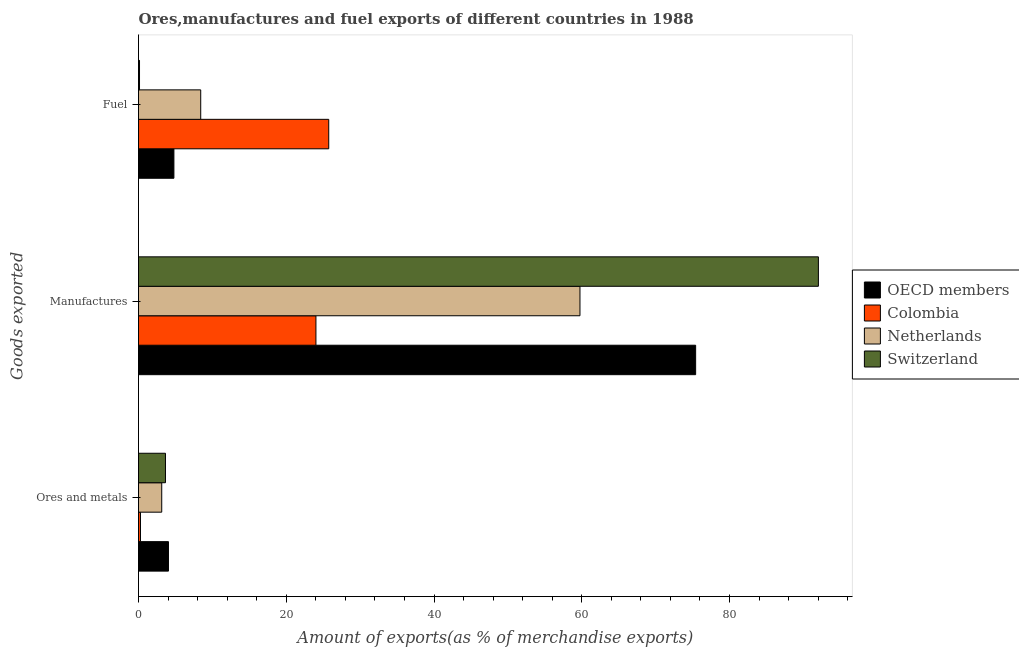How many different coloured bars are there?
Your response must be concise. 4. How many groups of bars are there?
Ensure brevity in your answer.  3. Are the number of bars per tick equal to the number of legend labels?
Your response must be concise. Yes. Are the number of bars on each tick of the Y-axis equal?
Make the answer very short. Yes. How many bars are there on the 3rd tick from the top?
Offer a terse response. 4. What is the label of the 1st group of bars from the top?
Offer a terse response. Fuel. What is the percentage of fuel exports in Netherlands?
Make the answer very short. 8.42. Across all countries, what is the maximum percentage of fuel exports?
Your response must be concise. 25.75. Across all countries, what is the minimum percentage of fuel exports?
Provide a short and direct response. 0.14. In which country was the percentage of manufactures exports maximum?
Provide a short and direct response. Switzerland. In which country was the percentage of fuel exports minimum?
Your answer should be compact. Switzerland. What is the total percentage of fuel exports in the graph?
Your response must be concise. 39.1. What is the difference between the percentage of fuel exports in Colombia and that in Switzerland?
Provide a short and direct response. 25.61. What is the difference between the percentage of manufactures exports in Switzerland and the percentage of ores and metals exports in Colombia?
Make the answer very short. 91.76. What is the average percentage of manufactures exports per country?
Your answer should be very brief. 62.81. What is the difference between the percentage of fuel exports and percentage of manufactures exports in Colombia?
Offer a very short reply. 1.73. What is the ratio of the percentage of ores and metals exports in Colombia to that in Switzerland?
Provide a succinct answer. 0.07. Is the percentage of fuel exports in Colombia less than that in Netherlands?
Give a very brief answer. No. Is the difference between the percentage of manufactures exports in Switzerland and Colombia greater than the difference between the percentage of ores and metals exports in Switzerland and Colombia?
Make the answer very short. Yes. What is the difference between the highest and the second highest percentage of manufactures exports?
Keep it short and to the point. 16.62. What is the difference between the highest and the lowest percentage of ores and metals exports?
Offer a very short reply. 3.79. In how many countries, is the percentage of fuel exports greater than the average percentage of fuel exports taken over all countries?
Keep it short and to the point. 1. Is the sum of the percentage of manufactures exports in Switzerland and Colombia greater than the maximum percentage of ores and metals exports across all countries?
Your answer should be very brief. Yes. What does the 1st bar from the top in Fuel represents?
Give a very brief answer. Switzerland. What does the 1st bar from the bottom in Manufactures represents?
Your answer should be compact. OECD members. Is it the case that in every country, the sum of the percentage of ores and metals exports and percentage of manufactures exports is greater than the percentage of fuel exports?
Offer a terse response. No. How many bars are there?
Your answer should be compact. 12. What is the difference between two consecutive major ticks on the X-axis?
Provide a succinct answer. 20. Where does the legend appear in the graph?
Offer a very short reply. Center right. How many legend labels are there?
Ensure brevity in your answer.  4. What is the title of the graph?
Provide a succinct answer. Ores,manufactures and fuel exports of different countries in 1988. What is the label or title of the X-axis?
Ensure brevity in your answer.  Amount of exports(as % of merchandise exports). What is the label or title of the Y-axis?
Give a very brief answer. Goods exported. What is the Amount of exports(as % of merchandise exports) in OECD members in Ores and metals?
Provide a succinct answer. 4.05. What is the Amount of exports(as % of merchandise exports) of Colombia in Ores and metals?
Ensure brevity in your answer.  0.27. What is the Amount of exports(as % of merchandise exports) in Netherlands in Ores and metals?
Offer a very short reply. 3.14. What is the Amount of exports(as % of merchandise exports) of Switzerland in Ores and metals?
Your answer should be very brief. 3.65. What is the Amount of exports(as % of merchandise exports) in OECD members in Manufactures?
Keep it short and to the point. 75.42. What is the Amount of exports(as % of merchandise exports) of Colombia in Manufactures?
Keep it short and to the point. 24.02. What is the Amount of exports(as % of merchandise exports) in Netherlands in Manufactures?
Your answer should be very brief. 59.76. What is the Amount of exports(as % of merchandise exports) of Switzerland in Manufactures?
Ensure brevity in your answer.  92.03. What is the Amount of exports(as % of merchandise exports) of OECD members in Fuel?
Make the answer very short. 4.79. What is the Amount of exports(as % of merchandise exports) in Colombia in Fuel?
Provide a succinct answer. 25.75. What is the Amount of exports(as % of merchandise exports) of Netherlands in Fuel?
Give a very brief answer. 8.42. What is the Amount of exports(as % of merchandise exports) of Switzerland in Fuel?
Keep it short and to the point. 0.14. Across all Goods exported, what is the maximum Amount of exports(as % of merchandise exports) in OECD members?
Provide a succinct answer. 75.42. Across all Goods exported, what is the maximum Amount of exports(as % of merchandise exports) in Colombia?
Make the answer very short. 25.75. Across all Goods exported, what is the maximum Amount of exports(as % of merchandise exports) in Netherlands?
Make the answer very short. 59.76. Across all Goods exported, what is the maximum Amount of exports(as % of merchandise exports) of Switzerland?
Your answer should be very brief. 92.03. Across all Goods exported, what is the minimum Amount of exports(as % of merchandise exports) in OECD members?
Your answer should be very brief. 4.05. Across all Goods exported, what is the minimum Amount of exports(as % of merchandise exports) of Colombia?
Your answer should be very brief. 0.27. Across all Goods exported, what is the minimum Amount of exports(as % of merchandise exports) of Netherlands?
Your response must be concise. 3.14. Across all Goods exported, what is the minimum Amount of exports(as % of merchandise exports) in Switzerland?
Offer a very short reply. 0.14. What is the total Amount of exports(as % of merchandise exports) in OECD members in the graph?
Your response must be concise. 84.26. What is the total Amount of exports(as % of merchandise exports) in Colombia in the graph?
Offer a terse response. 50.04. What is the total Amount of exports(as % of merchandise exports) of Netherlands in the graph?
Ensure brevity in your answer.  71.32. What is the total Amount of exports(as % of merchandise exports) of Switzerland in the graph?
Ensure brevity in your answer.  95.82. What is the difference between the Amount of exports(as % of merchandise exports) in OECD members in Ores and metals and that in Manufactures?
Offer a very short reply. -71.36. What is the difference between the Amount of exports(as % of merchandise exports) of Colombia in Ores and metals and that in Manufactures?
Make the answer very short. -23.75. What is the difference between the Amount of exports(as % of merchandise exports) of Netherlands in Ores and metals and that in Manufactures?
Provide a short and direct response. -56.62. What is the difference between the Amount of exports(as % of merchandise exports) in Switzerland in Ores and metals and that in Manufactures?
Your answer should be compact. -88.38. What is the difference between the Amount of exports(as % of merchandise exports) of OECD members in Ores and metals and that in Fuel?
Offer a terse response. -0.74. What is the difference between the Amount of exports(as % of merchandise exports) in Colombia in Ores and metals and that in Fuel?
Make the answer very short. -25.48. What is the difference between the Amount of exports(as % of merchandise exports) of Netherlands in Ores and metals and that in Fuel?
Make the answer very short. -5.28. What is the difference between the Amount of exports(as % of merchandise exports) of Switzerland in Ores and metals and that in Fuel?
Give a very brief answer. 3.51. What is the difference between the Amount of exports(as % of merchandise exports) in OECD members in Manufactures and that in Fuel?
Keep it short and to the point. 70.62. What is the difference between the Amount of exports(as % of merchandise exports) of Colombia in Manufactures and that in Fuel?
Give a very brief answer. -1.73. What is the difference between the Amount of exports(as % of merchandise exports) of Netherlands in Manufactures and that in Fuel?
Your answer should be very brief. 51.34. What is the difference between the Amount of exports(as % of merchandise exports) in Switzerland in Manufactures and that in Fuel?
Your answer should be compact. 91.9. What is the difference between the Amount of exports(as % of merchandise exports) in OECD members in Ores and metals and the Amount of exports(as % of merchandise exports) in Colombia in Manufactures?
Offer a terse response. -19.96. What is the difference between the Amount of exports(as % of merchandise exports) of OECD members in Ores and metals and the Amount of exports(as % of merchandise exports) of Netherlands in Manufactures?
Offer a very short reply. -55.7. What is the difference between the Amount of exports(as % of merchandise exports) of OECD members in Ores and metals and the Amount of exports(as % of merchandise exports) of Switzerland in Manufactures?
Ensure brevity in your answer.  -87.98. What is the difference between the Amount of exports(as % of merchandise exports) of Colombia in Ores and metals and the Amount of exports(as % of merchandise exports) of Netherlands in Manufactures?
Provide a short and direct response. -59.49. What is the difference between the Amount of exports(as % of merchandise exports) of Colombia in Ores and metals and the Amount of exports(as % of merchandise exports) of Switzerland in Manufactures?
Your answer should be very brief. -91.76. What is the difference between the Amount of exports(as % of merchandise exports) of Netherlands in Ores and metals and the Amount of exports(as % of merchandise exports) of Switzerland in Manufactures?
Your response must be concise. -88.89. What is the difference between the Amount of exports(as % of merchandise exports) of OECD members in Ores and metals and the Amount of exports(as % of merchandise exports) of Colombia in Fuel?
Make the answer very short. -21.7. What is the difference between the Amount of exports(as % of merchandise exports) in OECD members in Ores and metals and the Amount of exports(as % of merchandise exports) in Netherlands in Fuel?
Keep it short and to the point. -4.37. What is the difference between the Amount of exports(as % of merchandise exports) in OECD members in Ores and metals and the Amount of exports(as % of merchandise exports) in Switzerland in Fuel?
Your response must be concise. 3.92. What is the difference between the Amount of exports(as % of merchandise exports) in Colombia in Ores and metals and the Amount of exports(as % of merchandise exports) in Netherlands in Fuel?
Your answer should be very brief. -8.15. What is the difference between the Amount of exports(as % of merchandise exports) in Colombia in Ores and metals and the Amount of exports(as % of merchandise exports) in Switzerland in Fuel?
Make the answer very short. 0.13. What is the difference between the Amount of exports(as % of merchandise exports) of Netherlands in Ores and metals and the Amount of exports(as % of merchandise exports) of Switzerland in Fuel?
Provide a succinct answer. 3.01. What is the difference between the Amount of exports(as % of merchandise exports) of OECD members in Manufactures and the Amount of exports(as % of merchandise exports) of Colombia in Fuel?
Your answer should be compact. 49.67. What is the difference between the Amount of exports(as % of merchandise exports) of OECD members in Manufactures and the Amount of exports(as % of merchandise exports) of Netherlands in Fuel?
Offer a very short reply. 67. What is the difference between the Amount of exports(as % of merchandise exports) of OECD members in Manufactures and the Amount of exports(as % of merchandise exports) of Switzerland in Fuel?
Your answer should be compact. 75.28. What is the difference between the Amount of exports(as % of merchandise exports) of Colombia in Manufactures and the Amount of exports(as % of merchandise exports) of Netherlands in Fuel?
Your answer should be compact. 15.6. What is the difference between the Amount of exports(as % of merchandise exports) in Colombia in Manufactures and the Amount of exports(as % of merchandise exports) in Switzerland in Fuel?
Offer a terse response. 23.88. What is the difference between the Amount of exports(as % of merchandise exports) of Netherlands in Manufactures and the Amount of exports(as % of merchandise exports) of Switzerland in Fuel?
Give a very brief answer. 59.62. What is the average Amount of exports(as % of merchandise exports) in OECD members per Goods exported?
Offer a terse response. 28.09. What is the average Amount of exports(as % of merchandise exports) of Colombia per Goods exported?
Your answer should be very brief. 16.68. What is the average Amount of exports(as % of merchandise exports) of Netherlands per Goods exported?
Provide a succinct answer. 23.77. What is the average Amount of exports(as % of merchandise exports) of Switzerland per Goods exported?
Your answer should be very brief. 31.94. What is the difference between the Amount of exports(as % of merchandise exports) of OECD members and Amount of exports(as % of merchandise exports) of Colombia in Ores and metals?
Ensure brevity in your answer.  3.79. What is the difference between the Amount of exports(as % of merchandise exports) in OECD members and Amount of exports(as % of merchandise exports) in Netherlands in Ores and metals?
Your response must be concise. 0.91. What is the difference between the Amount of exports(as % of merchandise exports) of OECD members and Amount of exports(as % of merchandise exports) of Switzerland in Ores and metals?
Make the answer very short. 0.4. What is the difference between the Amount of exports(as % of merchandise exports) in Colombia and Amount of exports(as % of merchandise exports) in Netherlands in Ores and metals?
Keep it short and to the point. -2.87. What is the difference between the Amount of exports(as % of merchandise exports) of Colombia and Amount of exports(as % of merchandise exports) of Switzerland in Ores and metals?
Make the answer very short. -3.38. What is the difference between the Amount of exports(as % of merchandise exports) in Netherlands and Amount of exports(as % of merchandise exports) in Switzerland in Ores and metals?
Provide a succinct answer. -0.51. What is the difference between the Amount of exports(as % of merchandise exports) of OECD members and Amount of exports(as % of merchandise exports) of Colombia in Manufactures?
Your response must be concise. 51.4. What is the difference between the Amount of exports(as % of merchandise exports) in OECD members and Amount of exports(as % of merchandise exports) in Netherlands in Manufactures?
Offer a terse response. 15.66. What is the difference between the Amount of exports(as % of merchandise exports) of OECD members and Amount of exports(as % of merchandise exports) of Switzerland in Manufactures?
Offer a terse response. -16.62. What is the difference between the Amount of exports(as % of merchandise exports) of Colombia and Amount of exports(as % of merchandise exports) of Netherlands in Manufactures?
Provide a short and direct response. -35.74. What is the difference between the Amount of exports(as % of merchandise exports) of Colombia and Amount of exports(as % of merchandise exports) of Switzerland in Manufactures?
Your response must be concise. -68.01. What is the difference between the Amount of exports(as % of merchandise exports) in Netherlands and Amount of exports(as % of merchandise exports) in Switzerland in Manufactures?
Make the answer very short. -32.27. What is the difference between the Amount of exports(as % of merchandise exports) in OECD members and Amount of exports(as % of merchandise exports) in Colombia in Fuel?
Provide a short and direct response. -20.96. What is the difference between the Amount of exports(as % of merchandise exports) in OECD members and Amount of exports(as % of merchandise exports) in Netherlands in Fuel?
Make the answer very short. -3.63. What is the difference between the Amount of exports(as % of merchandise exports) in OECD members and Amount of exports(as % of merchandise exports) in Switzerland in Fuel?
Offer a very short reply. 4.66. What is the difference between the Amount of exports(as % of merchandise exports) in Colombia and Amount of exports(as % of merchandise exports) in Netherlands in Fuel?
Ensure brevity in your answer.  17.33. What is the difference between the Amount of exports(as % of merchandise exports) of Colombia and Amount of exports(as % of merchandise exports) of Switzerland in Fuel?
Provide a succinct answer. 25.61. What is the difference between the Amount of exports(as % of merchandise exports) of Netherlands and Amount of exports(as % of merchandise exports) of Switzerland in Fuel?
Give a very brief answer. 8.28. What is the ratio of the Amount of exports(as % of merchandise exports) in OECD members in Ores and metals to that in Manufactures?
Your response must be concise. 0.05. What is the ratio of the Amount of exports(as % of merchandise exports) of Colombia in Ores and metals to that in Manufactures?
Offer a very short reply. 0.01. What is the ratio of the Amount of exports(as % of merchandise exports) in Netherlands in Ores and metals to that in Manufactures?
Provide a succinct answer. 0.05. What is the ratio of the Amount of exports(as % of merchandise exports) in Switzerland in Ores and metals to that in Manufactures?
Keep it short and to the point. 0.04. What is the ratio of the Amount of exports(as % of merchandise exports) in OECD members in Ores and metals to that in Fuel?
Provide a succinct answer. 0.85. What is the ratio of the Amount of exports(as % of merchandise exports) in Colombia in Ores and metals to that in Fuel?
Your answer should be very brief. 0.01. What is the ratio of the Amount of exports(as % of merchandise exports) in Netherlands in Ores and metals to that in Fuel?
Keep it short and to the point. 0.37. What is the ratio of the Amount of exports(as % of merchandise exports) in Switzerland in Ores and metals to that in Fuel?
Provide a succinct answer. 26.87. What is the ratio of the Amount of exports(as % of merchandise exports) of OECD members in Manufactures to that in Fuel?
Make the answer very short. 15.74. What is the ratio of the Amount of exports(as % of merchandise exports) in Colombia in Manufactures to that in Fuel?
Keep it short and to the point. 0.93. What is the ratio of the Amount of exports(as % of merchandise exports) in Netherlands in Manufactures to that in Fuel?
Provide a short and direct response. 7.1. What is the ratio of the Amount of exports(as % of merchandise exports) of Switzerland in Manufactures to that in Fuel?
Your answer should be compact. 677.49. What is the difference between the highest and the second highest Amount of exports(as % of merchandise exports) of OECD members?
Provide a short and direct response. 70.62. What is the difference between the highest and the second highest Amount of exports(as % of merchandise exports) in Colombia?
Provide a short and direct response. 1.73. What is the difference between the highest and the second highest Amount of exports(as % of merchandise exports) in Netherlands?
Keep it short and to the point. 51.34. What is the difference between the highest and the second highest Amount of exports(as % of merchandise exports) of Switzerland?
Provide a short and direct response. 88.38. What is the difference between the highest and the lowest Amount of exports(as % of merchandise exports) of OECD members?
Provide a short and direct response. 71.36. What is the difference between the highest and the lowest Amount of exports(as % of merchandise exports) of Colombia?
Provide a succinct answer. 25.48. What is the difference between the highest and the lowest Amount of exports(as % of merchandise exports) in Netherlands?
Your response must be concise. 56.62. What is the difference between the highest and the lowest Amount of exports(as % of merchandise exports) in Switzerland?
Your answer should be compact. 91.9. 